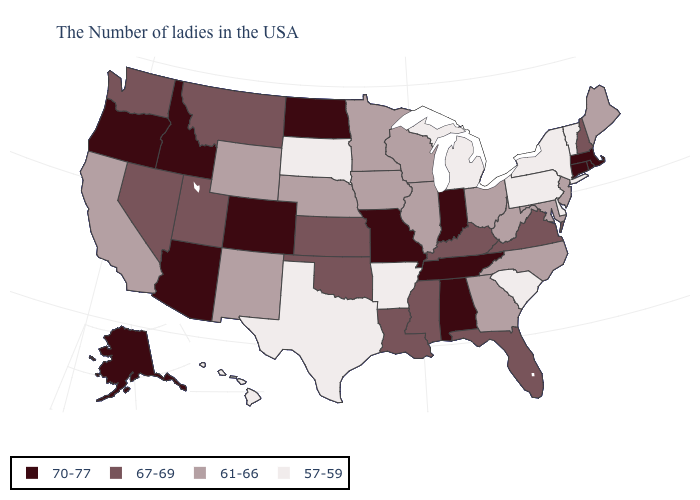Name the states that have a value in the range 57-59?
Be succinct. Vermont, New York, Delaware, Pennsylvania, South Carolina, Michigan, Arkansas, Texas, South Dakota, Hawaii. Name the states that have a value in the range 57-59?
Answer briefly. Vermont, New York, Delaware, Pennsylvania, South Carolina, Michigan, Arkansas, Texas, South Dakota, Hawaii. Does Massachusetts have a higher value than Indiana?
Write a very short answer. No. Among the states that border New York , does Massachusetts have the highest value?
Give a very brief answer. Yes. Among the states that border New York , does Massachusetts have the highest value?
Keep it brief. Yes. What is the value of Kentucky?
Give a very brief answer. 67-69. Name the states that have a value in the range 61-66?
Quick response, please. Maine, New Jersey, Maryland, North Carolina, West Virginia, Ohio, Georgia, Wisconsin, Illinois, Minnesota, Iowa, Nebraska, Wyoming, New Mexico, California. Among the states that border New Hampshire , does Massachusetts have the highest value?
Quick response, please. Yes. Among the states that border Oklahoma , which have the highest value?
Concise answer only. Missouri, Colorado. What is the lowest value in the South?
Answer briefly. 57-59. What is the highest value in the USA?
Short answer required. 70-77. What is the lowest value in the USA?
Be succinct. 57-59. Among the states that border Mississippi , which have the highest value?
Concise answer only. Alabama, Tennessee. Among the states that border West Virginia , does Maryland have the lowest value?
Short answer required. No. What is the highest value in the South ?
Answer briefly. 70-77. 